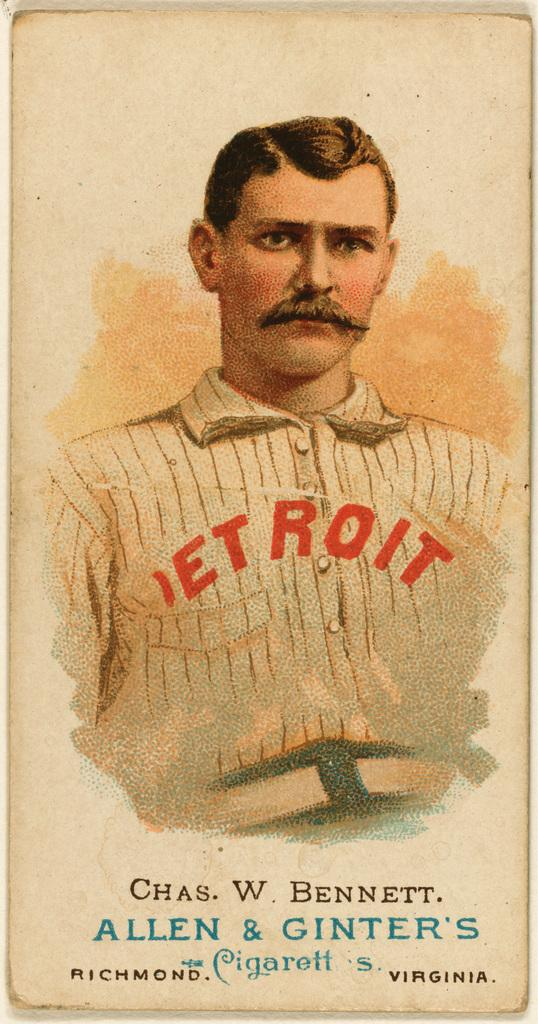What is the main subject of the image? The image might depict a book. Can you describe the person in the image? There is a person in the center of the image. Where is the text located in the image? The text is at the bottom of the image. How does the beginner use the box in the image? There is no box present in the image, and therefore no such interaction can be observed. 